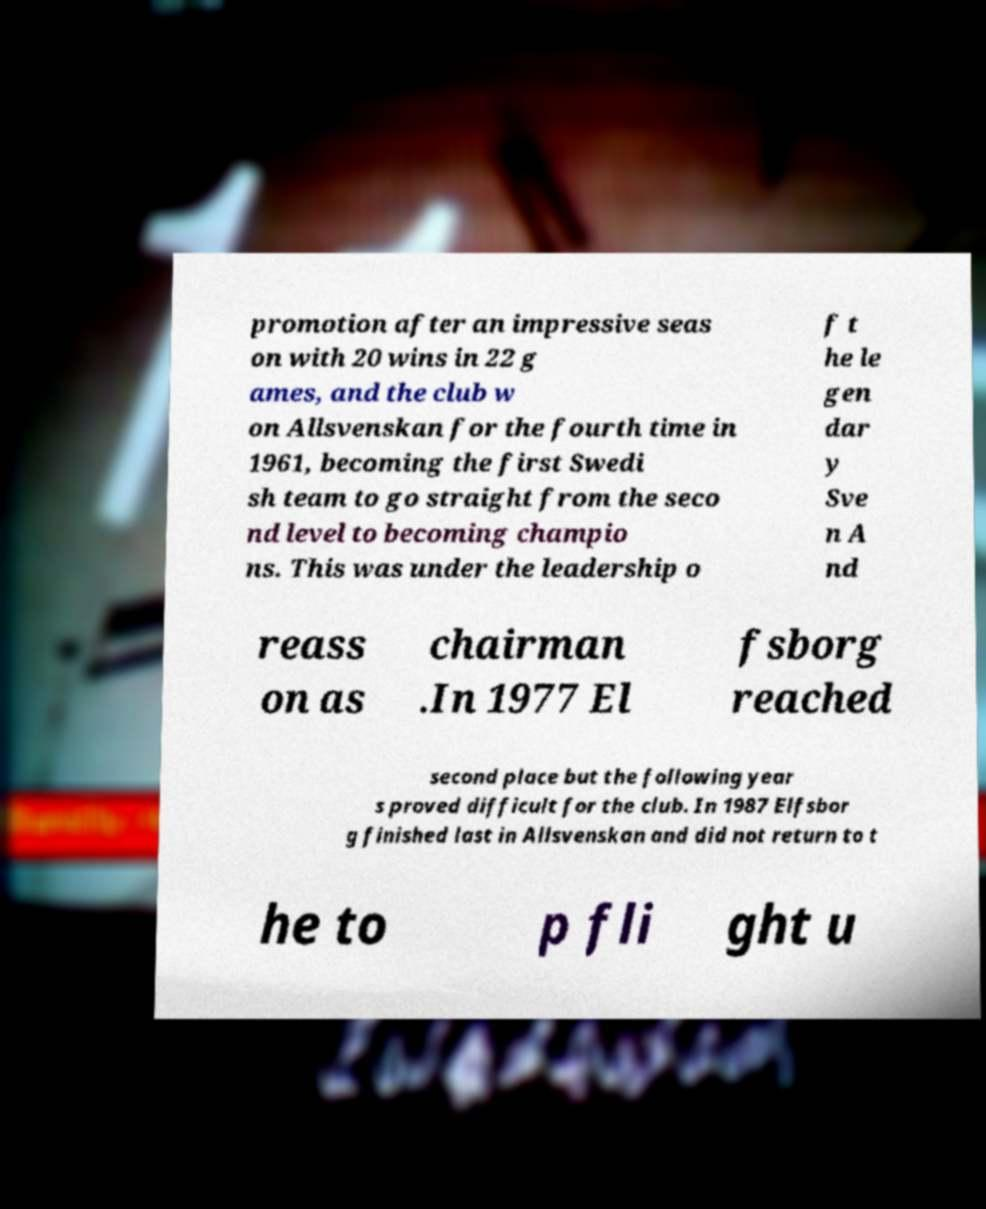What messages or text are displayed in this image? I need them in a readable, typed format. promotion after an impressive seas on with 20 wins in 22 g ames, and the club w on Allsvenskan for the fourth time in 1961, becoming the first Swedi sh team to go straight from the seco nd level to becoming champio ns. This was under the leadership o f t he le gen dar y Sve n A nd reass on as chairman .In 1977 El fsborg reached second place but the following year s proved difficult for the club. In 1987 Elfsbor g finished last in Allsvenskan and did not return to t he to p fli ght u 